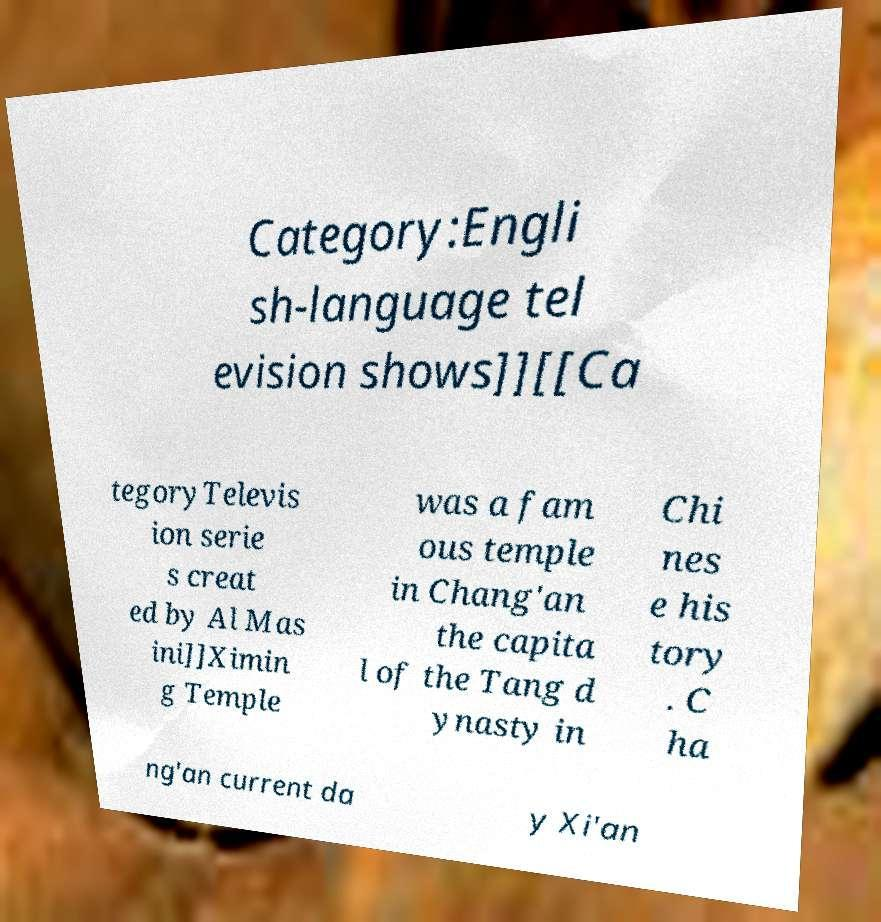Could you extract and type out the text from this image? Category:Engli sh-language tel evision shows]][[Ca tegoryTelevis ion serie s creat ed by Al Mas ini]]Ximin g Temple was a fam ous temple in Chang'an the capita l of the Tang d ynasty in Chi nes e his tory . C ha ng'an current da y Xi'an 